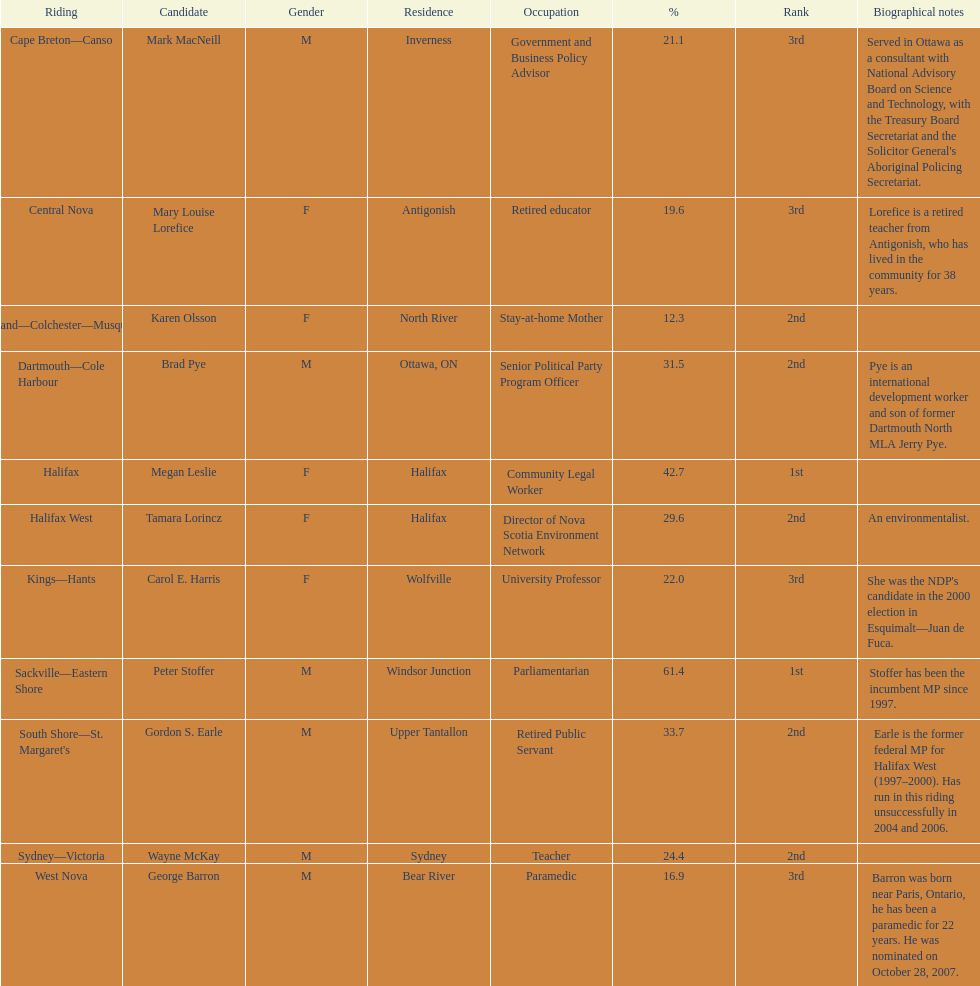Who got a larger number of votes, macneill or olsson? Mark MacNeill. 